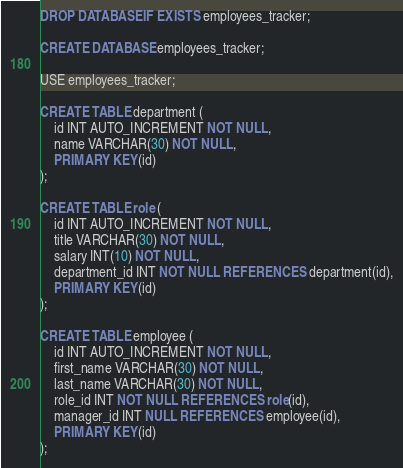Convert code to text. <code><loc_0><loc_0><loc_500><loc_500><_SQL_>DROP DATABASE IF EXISTS employees_tracker;

CREATE DATABASE employees_tracker;

USE employees_tracker;

CREATE TABLE department (
    id INT AUTO_INCREMENT NOT NULL,
    name VARCHAR(30) NOT NULL,
    PRIMARY KEY(id)
);

CREATE TABLE role (
    id INT AUTO_INCREMENT NOT NULL,
    title VARCHAR(30) NOT NULL,
    salary INT(10) NOT NULL,
    department_id INT NOT NULL REFERENCES department(id),
    PRIMARY KEY(id)
);

CREATE TABLE employee (
    id INT AUTO_INCREMENT NOT NULL,
    first_name VARCHAR(30) NOT NULL,
    last_name VARCHAR(30) NOT NULL,
    role_id INT NOT NULL REFERENCES role(id),
    manager_id INT NULL REFERENCES employee(id),
    PRIMARY KEY(id)
);
</code> 